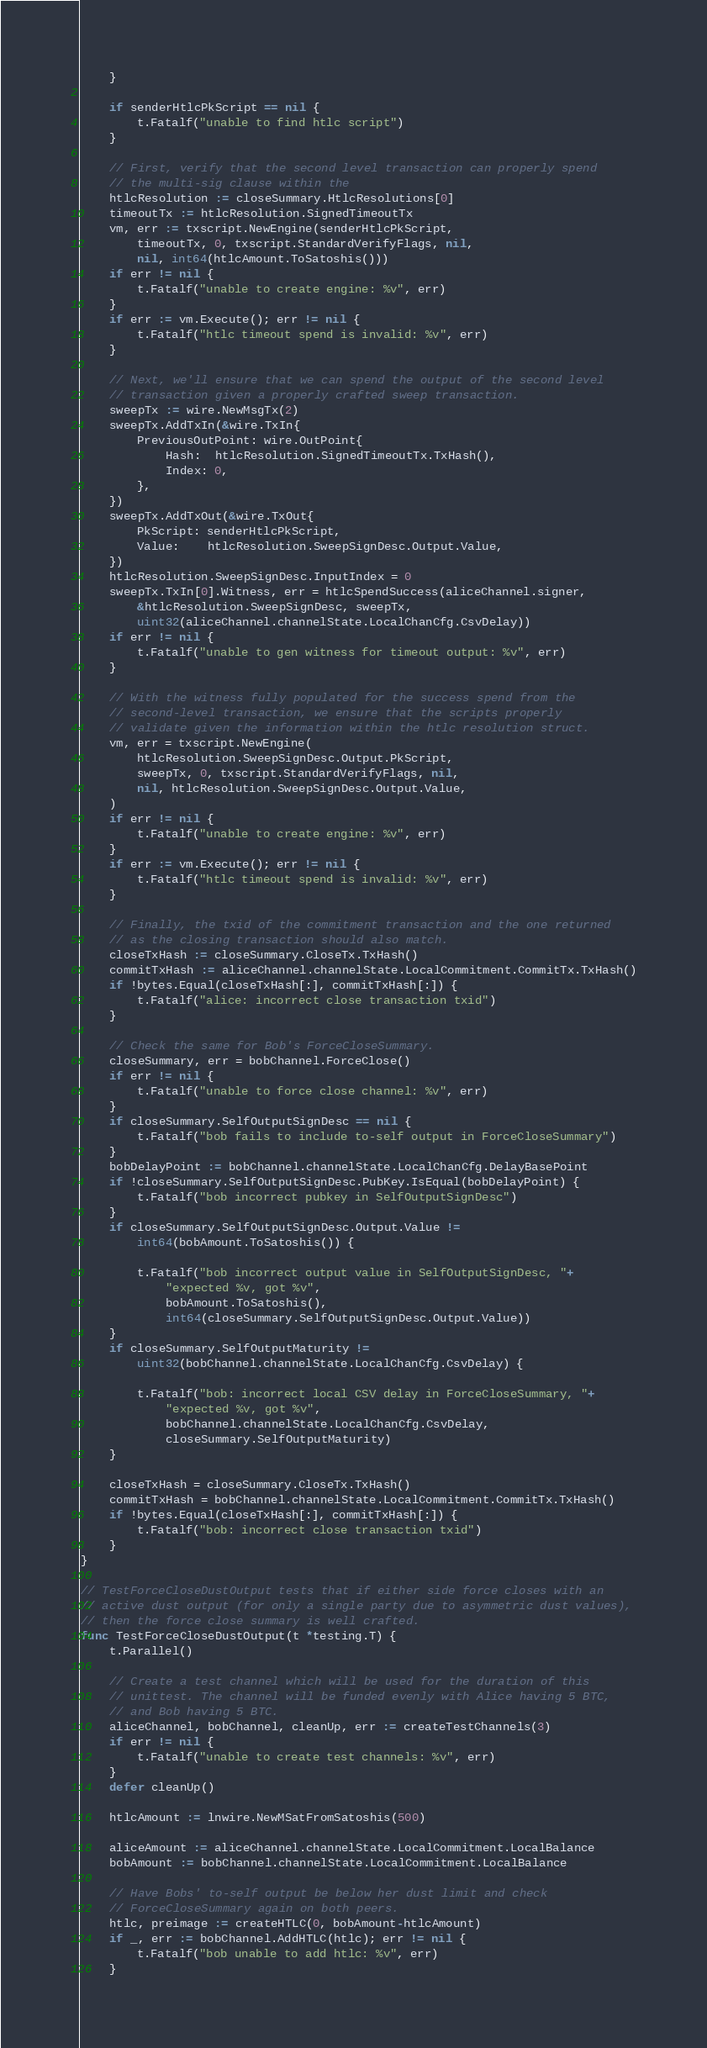Convert code to text. <code><loc_0><loc_0><loc_500><loc_500><_Go_>	}

	if senderHtlcPkScript == nil {
		t.Fatalf("unable to find htlc script")
	}

	// First, verify that the second level transaction can properly spend
	// the multi-sig clause within the
	htlcResolution := closeSummary.HtlcResolutions[0]
	timeoutTx := htlcResolution.SignedTimeoutTx
	vm, err := txscript.NewEngine(senderHtlcPkScript,
		timeoutTx, 0, txscript.StandardVerifyFlags, nil,
		nil, int64(htlcAmount.ToSatoshis()))
	if err != nil {
		t.Fatalf("unable to create engine: %v", err)
	}
	if err := vm.Execute(); err != nil {
		t.Fatalf("htlc timeout spend is invalid: %v", err)
	}

	// Next, we'll ensure that we can spend the output of the second level
	// transaction given a properly crafted sweep transaction.
	sweepTx := wire.NewMsgTx(2)
	sweepTx.AddTxIn(&wire.TxIn{
		PreviousOutPoint: wire.OutPoint{
			Hash:  htlcResolution.SignedTimeoutTx.TxHash(),
			Index: 0,
		},
	})
	sweepTx.AddTxOut(&wire.TxOut{
		PkScript: senderHtlcPkScript,
		Value:    htlcResolution.SweepSignDesc.Output.Value,
	})
	htlcResolution.SweepSignDesc.InputIndex = 0
	sweepTx.TxIn[0].Witness, err = htlcSpendSuccess(aliceChannel.signer,
		&htlcResolution.SweepSignDesc, sweepTx,
		uint32(aliceChannel.channelState.LocalChanCfg.CsvDelay))
	if err != nil {
		t.Fatalf("unable to gen witness for timeout output: %v", err)
	}

	// With the witness fully populated for the success spend from the
	// second-level transaction, we ensure that the scripts properly
	// validate given the information within the htlc resolution struct.
	vm, err = txscript.NewEngine(
		htlcResolution.SweepSignDesc.Output.PkScript,
		sweepTx, 0, txscript.StandardVerifyFlags, nil,
		nil, htlcResolution.SweepSignDesc.Output.Value,
	)
	if err != nil {
		t.Fatalf("unable to create engine: %v", err)
	}
	if err := vm.Execute(); err != nil {
		t.Fatalf("htlc timeout spend is invalid: %v", err)
	}

	// Finally, the txid of the commitment transaction and the one returned
	// as the closing transaction should also match.
	closeTxHash := closeSummary.CloseTx.TxHash()
	commitTxHash := aliceChannel.channelState.LocalCommitment.CommitTx.TxHash()
	if !bytes.Equal(closeTxHash[:], commitTxHash[:]) {
		t.Fatalf("alice: incorrect close transaction txid")
	}

	// Check the same for Bob's ForceCloseSummary.
	closeSummary, err = bobChannel.ForceClose()
	if err != nil {
		t.Fatalf("unable to force close channel: %v", err)
	}
	if closeSummary.SelfOutputSignDesc == nil {
		t.Fatalf("bob fails to include to-self output in ForceCloseSummary")
	}
	bobDelayPoint := bobChannel.channelState.LocalChanCfg.DelayBasePoint
	if !closeSummary.SelfOutputSignDesc.PubKey.IsEqual(bobDelayPoint) {
		t.Fatalf("bob incorrect pubkey in SelfOutputSignDesc")
	}
	if closeSummary.SelfOutputSignDesc.Output.Value !=
		int64(bobAmount.ToSatoshis()) {

		t.Fatalf("bob incorrect output value in SelfOutputSignDesc, "+
			"expected %v, got %v",
			bobAmount.ToSatoshis(),
			int64(closeSummary.SelfOutputSignDesc.Output.Value))
	}
	if closeSummary.SelfOutputMaturity !=
		uint32(bobChannel.channelState.LocalChanCfg.CsvDelay) {

		t.Fatalf("bob: incorrect local CSV delay in ForceCloseSummary, "+
			"expected %v, got %v",
			bobChannel.channelState.LocalChanCfg.CsvDelay,
			closeSummary.SelfOutputMaturity)
	}

	closeTxHash = closeSummary.CloseTx.TxHash()
	commitTxHash = bobChannel.channelState.LocalCommitment.CommitTx.TxHash()
	if !bytes.Equal(closeTxHash[:], commitTxHash[:]) {
		t.Fatalf("bob: incorrect close transaction txid")
	}
}

// TestForceCloseDustOutput tests that if either side force closes with an
// active dust output (for only a single party due to asymmetric dust values),
// then the force close summary is well crafted.
func TestForceCloseDustOutput(t *testing.T) {
	t.Parallel()

	// Create a test channel which will be used for the duration of this
	// unittest. The channel will be funded evenly with Alice having 5 BTC,
	// and Bob having 5 BTC.
	aliceChannel, bobChannel, cleanUp, err := createTestChannels(3)
	if err != nil {
		t.Fatalf("unable to create test channels: %v", err)
	}
	defer cleanUp()

	htlcAmount := lnwire.NewMSatFromSatoshis(500)

	aliceAmount := aliceChannel.channelState.LocalCommitment.LocalBalance
	bobAmount := bobChannel.channelState.LocalCommitment.LocalBalance

	// Have Bobs' to-self output be below her dust limit and check
	// ForceCloseSummary again on both peers.
	htlc, preimage := createHTLC(0, bobAmount-htlcAmount)
	if _, err := bobChannel.AddHTLC(htlc); err != nil {
		t.Fatalf("bob unable to add htlc: %v", err)
	}</code> 